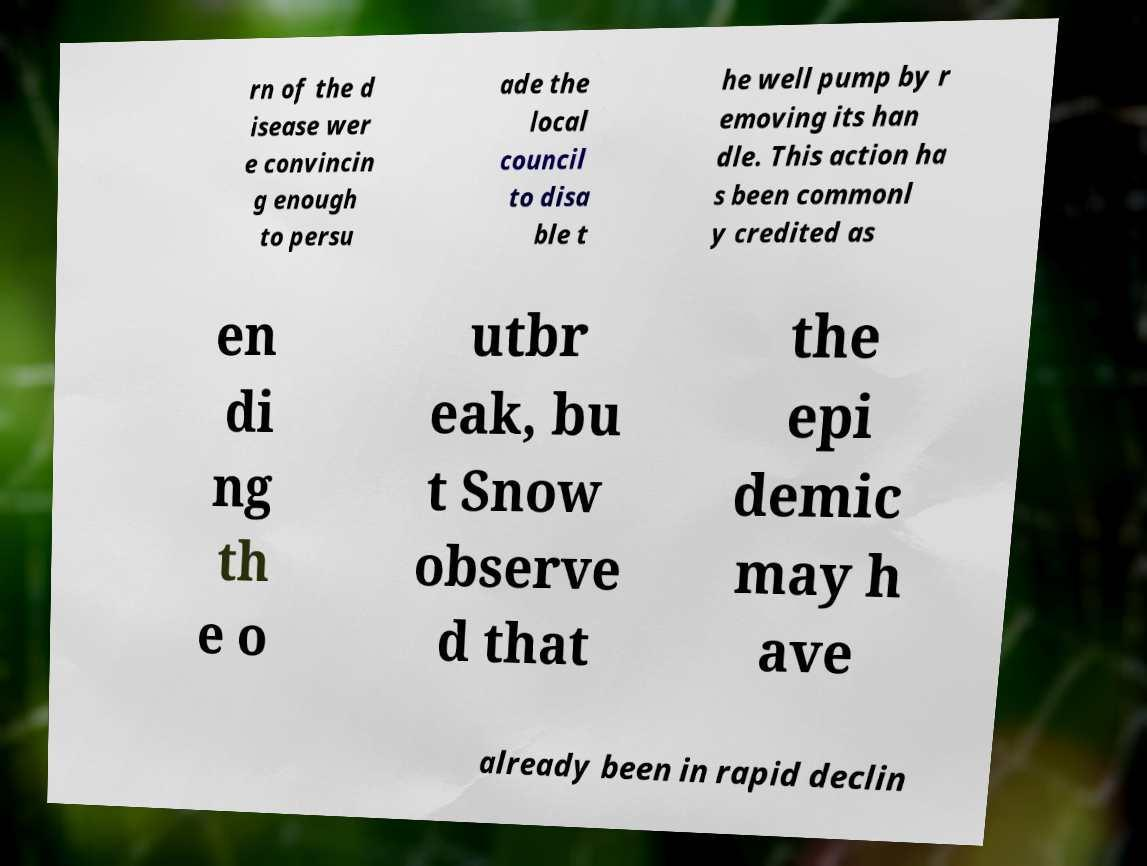Could you extract and type out the text from this image? rn of the d isease wer e convincin g enough to persu ade the local council to disa ble t he well pump by r emoving its han dle. This action ha s been commonl y credited as en di ng th e o utbr eak, bu t Snow observe d that the epi demic may h ave already been in rapid declin 